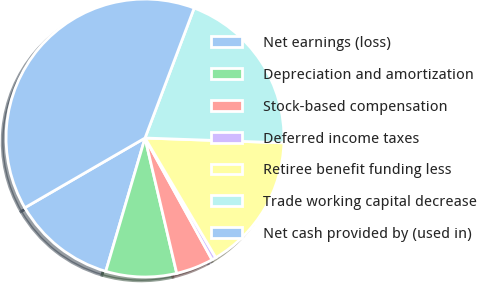Convert chart. <chart><loc_0><loc_0><loc_500><loc_500><pie_chart><fcel>Net earnings (loss)<fcel>Depreciation and amortization<fcel>Stock-based compensation<fcel>Deferred income taxes<fcel>Retiree benefit funding less<fcel>Trade working capital decrease<fcel>Net cash provided by (used in)<nl><fcel>12.08%<fcel>8.22%<fcel>4.35%<fcel>0.49%<fcel>15.94%<fcel>19.8%<fcel>39.12%<nl></chart> 